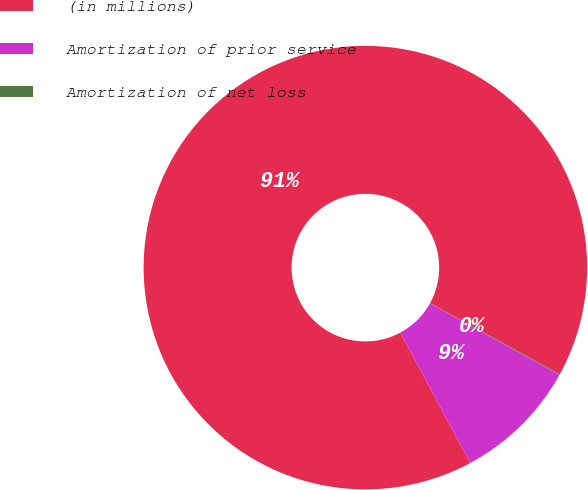<chart> <loc_0><loc_0><loc_500><loc_500><pie_chart><fcel>(in millions)<fcel>Amortization of prior service<fcel>Amortization of net loss<nl><fcel>90.83%<fcel>9.12%<fcel>0.05%<nl></chart> 